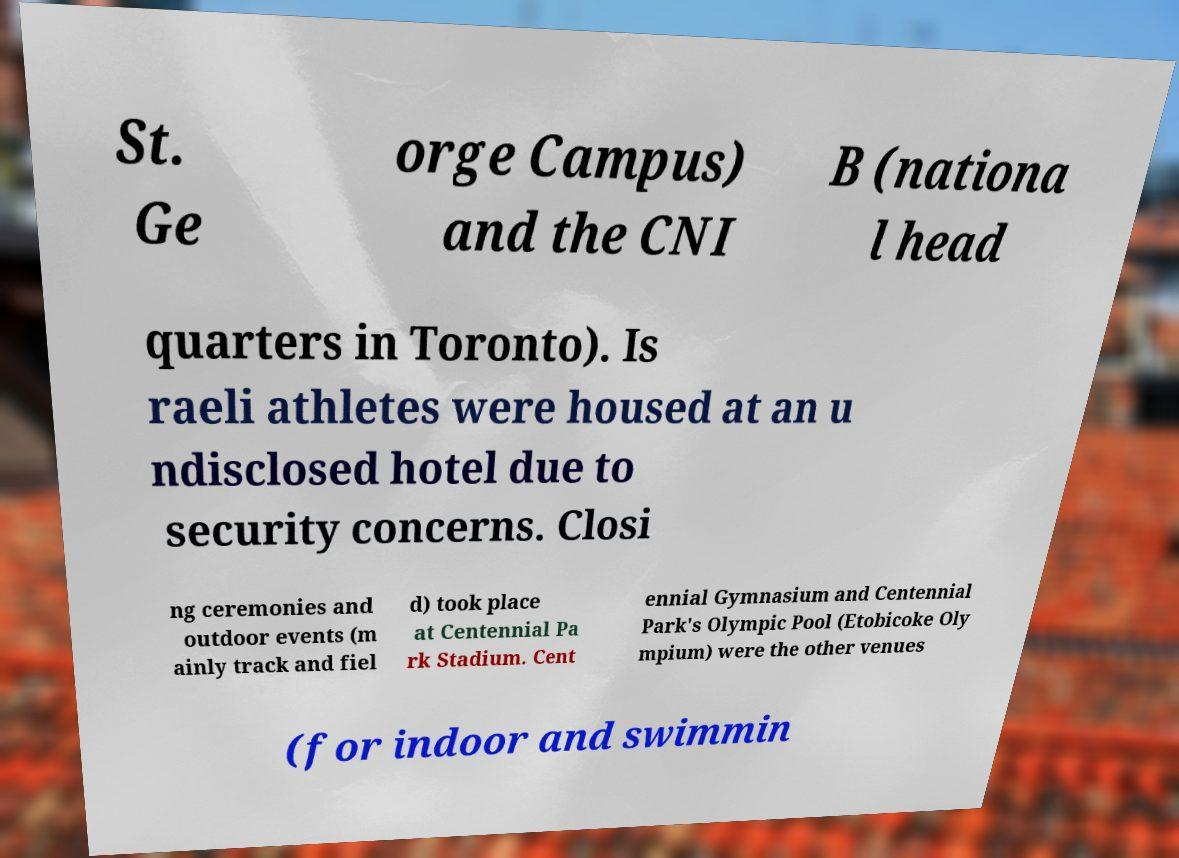Could you assist in decoding the text presented in this image and type it out clearly? St. Ge orge Campus) and the CNI B (nationa l head quarters in Toronto). Is raeli athletes were housed at an u ndisclosed hotel due to security concerns. Closi ng ceremonies and outdoor events (m ainly track and fiel d) took place at Centennial Pa rk Stadium. Cent ennial Gymnasium and Centennial Park's Olympic Pool (Etobicoke Oly mpium) were the other venues (for indoor and swimmin 